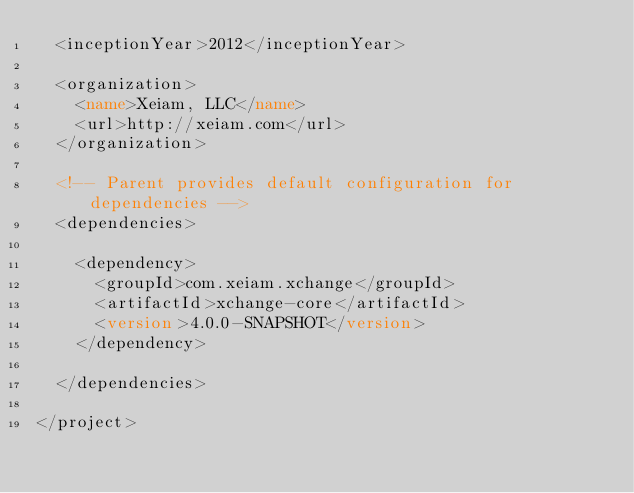Convert code to text. <code><loc_0><loc_0><loc_500><loc_500><_XML_>	<inceptionYear>2012</inceptionYear>

	<organization>
		<name>Xeiam, LLC</name>
		<url>http://xeiam.com</url>
	</organization>

	<!-- Parent provides default configuration for dependencies -->
	<dependencies>

		<dependency>
			<groupId>com.xeiam.xchange</groupId>
			<artifactId>xchange-core</artifactId>
			<version>4.0.0-SNAPSHOT</version>
		</dependency>

	</dependencies>

</project></code> 